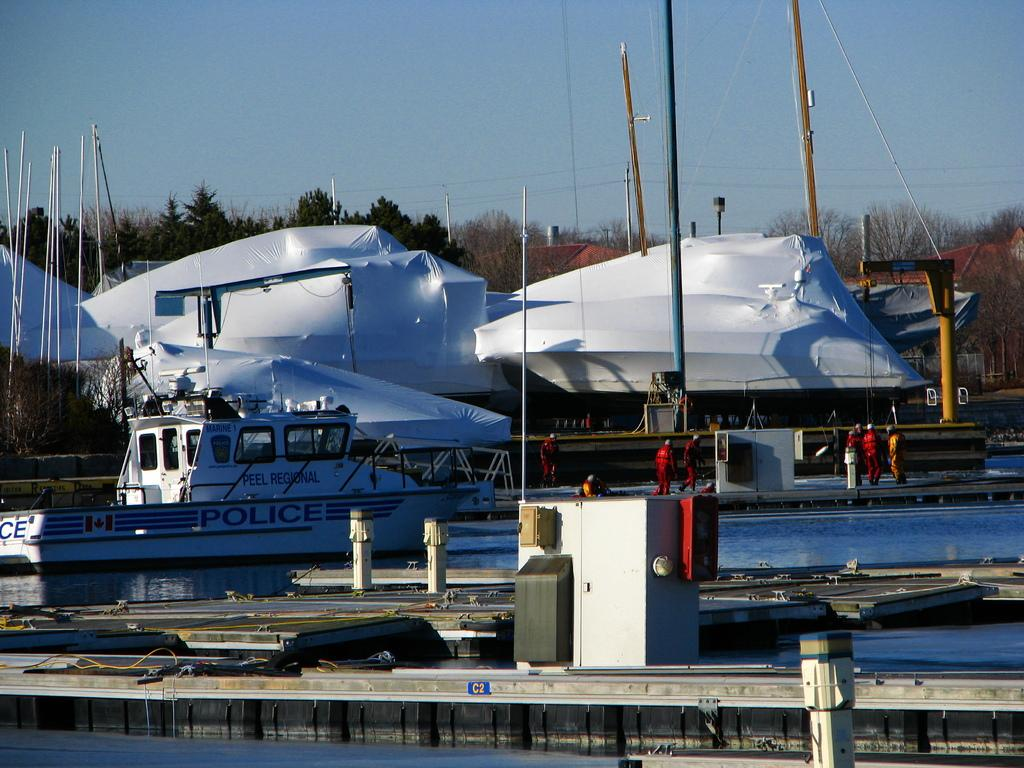<image>
Share a concise interpretation of the image provided. A peel regional police boat in a harbour. 